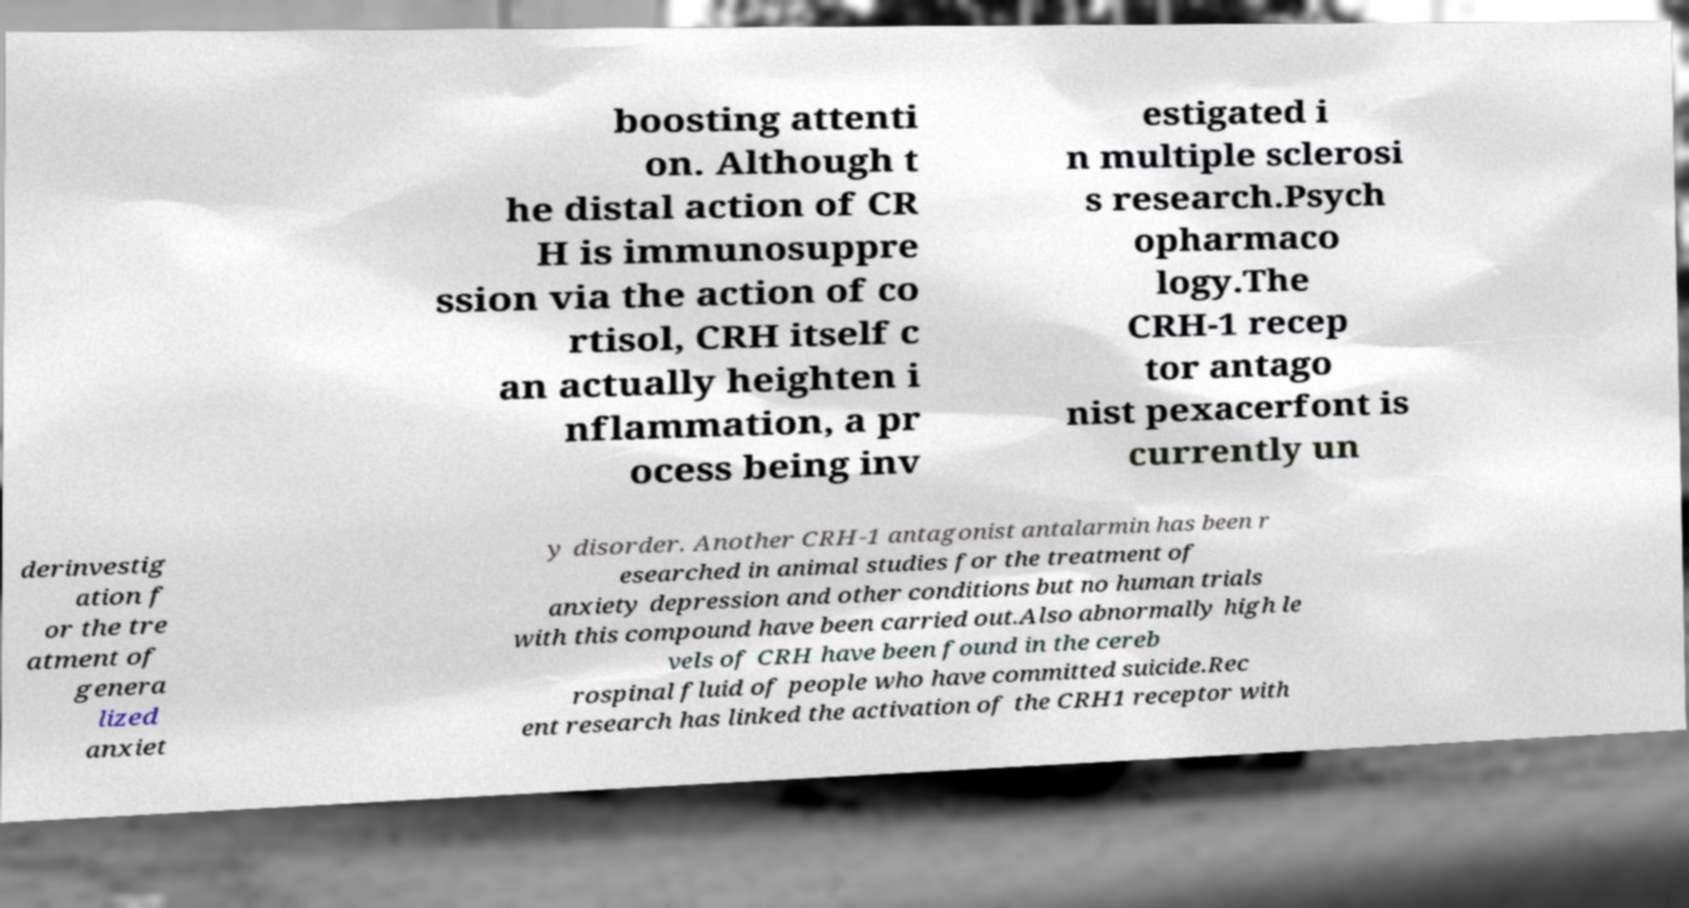Could you extract and type out the text from this image? boosting attenti on. Although t he distal action of CR H is immunosuppre ssion via the action of co rtisol, CRH itself c an actually heighten i nflammation, a pr ocess being inv estigated i n multiple sclerosi s research.Psych opharmaco logy.The CRH-1 recep tor antago nist pexacerfont is currently un derinvestig ation f or the tre atment of genera lized anxiet y disorder. Another CRH-1 antagonist antalarmin has been r esearched in animal studies for the treatment of anxiety depression and other conditions but no human trials with this compound have been carried out.Also abnormally high le vels of CRH have been found in the cereb rospinal fluid of people who have committed suicide.Rec ent research has linked the activation of the CRH1 receptor with 